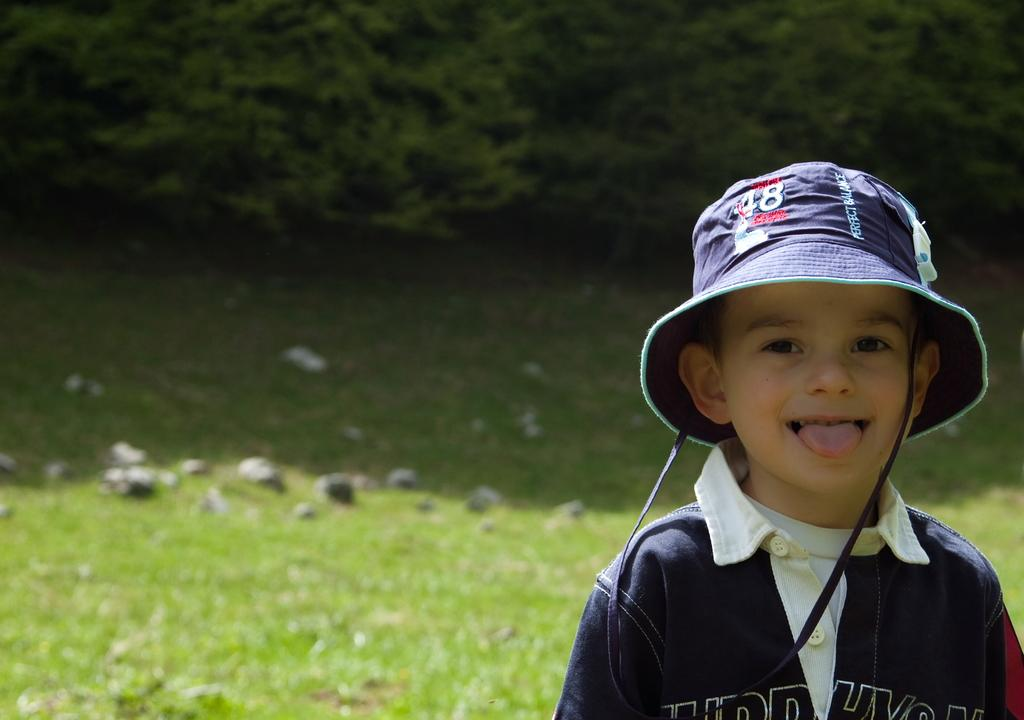Who is in the image? There is a boy in the image. What is the boy doing in the image? The boy is standing in the image. What is the boy wearing on his head? The boy is wearing a cap on his head. What type of ground is visible in the image? There is grass on the ground in the image. What other objects can be seen on the ground? There are stones visible in the image. What type of vegetation is present in the image? There are trees in the image. What color is the boy's t-shirt? The boy is wearing a blue t-shirt. What caption is written on the boy's t-shirt in the image? There is no caption visible on the boy's t-shirt in the image. 